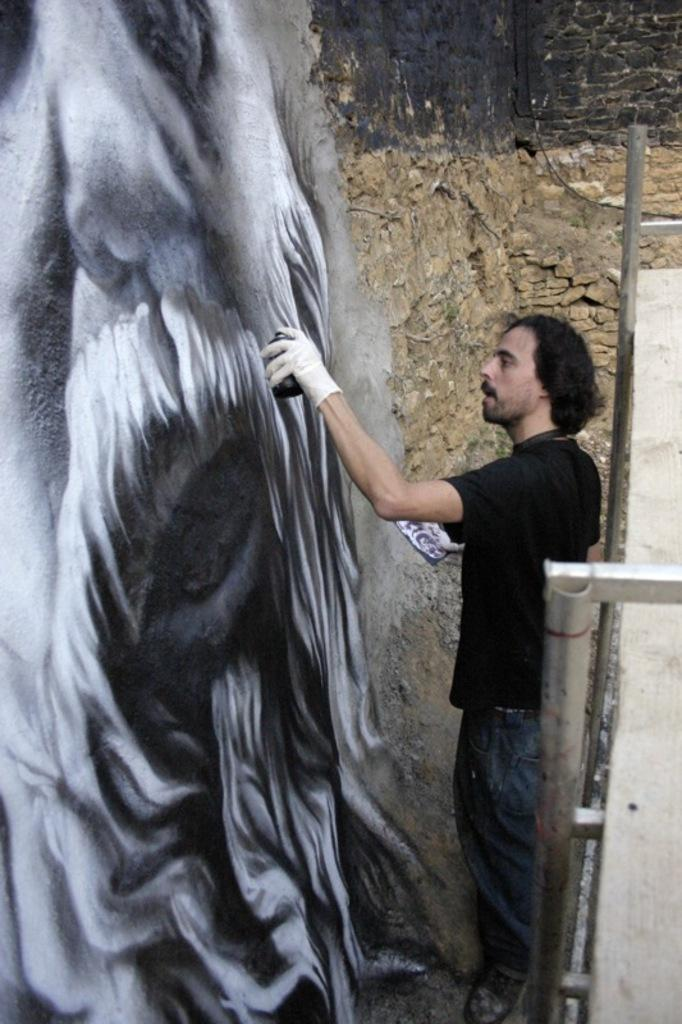What is the person in the image doing? The person in the image is painting. What is the person painting on? The person is painting on a wall. Are there any other objects or features visible in the image? Yes, there are rods visible in the image. What type of mitten is the person wearing while painting in the image? There is no mitten visible in the image, as the person is not wearing any gloves or mittens while painting. 